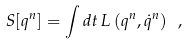<formula> <loc_0><loc_0><loc_500><loc_500>S [ q ^ { n } ] = \int d t \, L \left ( q ^ { n } , \dot { q } ^ { n } \right ) \ ,</formula> 